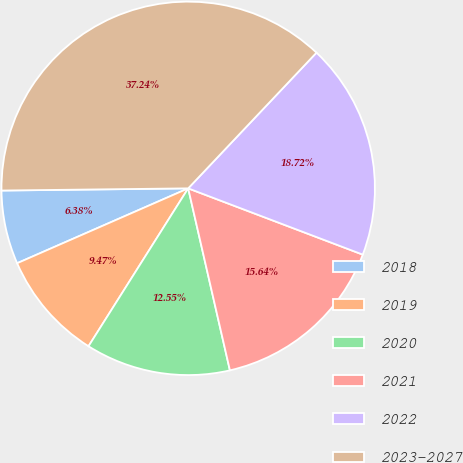<chart> <loc_0><loc_0><loc_500><loc_500><pie_chart><fcel>2018<fcel>2019<fcel>2020<fcel>2021<fcel>2022<fcel>2023-2027<nl><fcel>6.38%<fcel>9.47%<fcel>12.55%<fcel>15.64%<fcel>18.72%<fcel>37.24%<nl></chart> 